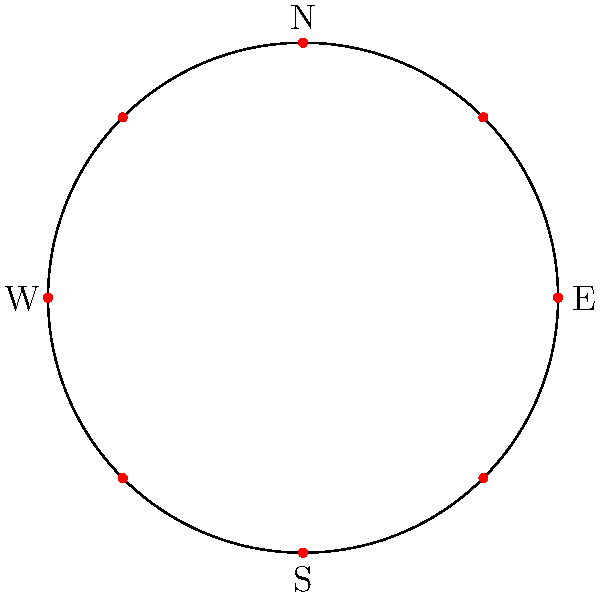A circular city has 8 recycling facilities evenly distributed along its perimeter. If the first facility is located at 0° (due East), what is the angular separation between each facility, and at what angle (in degrees) is the facility located closest to the Northwest direction? To solve this problem, let's follow these steps:

1. Calculate the angular separation between facilities:
   - There are 8 facilities evenly distributed around a circle (360°)
   - Angular separation = $\frac{360°}{8} = 45°$

2. Determine the angles for all facilities:
   - Facility 1: 0° (given)
   - Facility 2: 45°
   - Facility 3: 90°
   - Facility 4: 135°
   - Facility 5: 180°
   - Facility 6: 225°
   - Facility 7: 270°
   - Facility 8: 315°

3. Identify the Northwest direction:
   - Northwest is at 315° (between West at 270° and North at 0°/360°)

4. Find the facility closest to Northwest:
   - Facility 8 is exactly at 315°, which is the Northwest direction

Therefore, the angular separation between each facility is 45°, and the facility located closest to the Northwest direction is at an angle of 315°.
Answer: 45°; 315° 